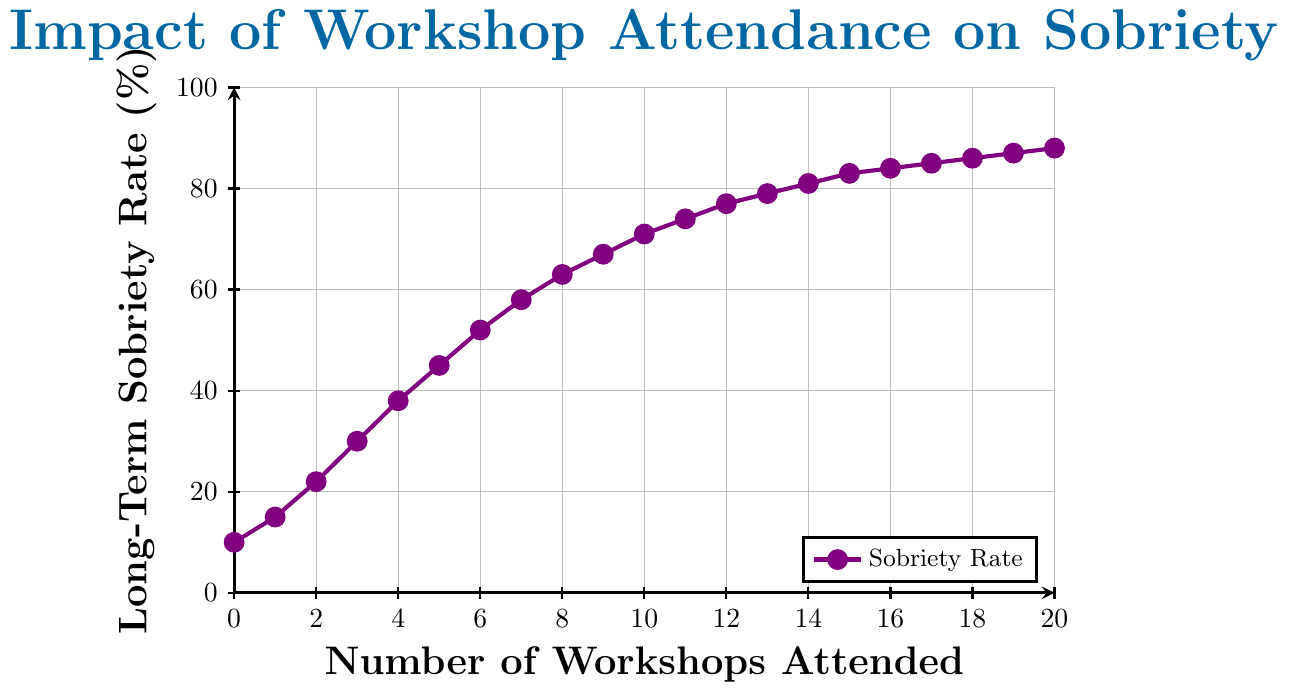What's the trend in long-term sobriety rates as the number of workshops attended increases? Observing the line plot, the long-term sobriety rate increases steadily as the number of workshops attended goes up, starting at 10% for 0 workshops and gradually reaching 88% for 20 workshops.
Answer: Increasing How much does the long-term sobriety rate improve after attending 5 workshops as opposed to attending none? The sobriety rate for 0 workshops is 10%, and for 5 workshops is 45%. The improvement is 45% - 10% = 35%.
Answer: 35% At what point on the number of workshops attended axis does the long-term sobriety rate first surpass 50%? Looking at the line plot, the sobriety rate first surpasses 50% between attending 5 and 6 workshops.
Answer: Between 5 and 6 workshops What is the average long-term sobriety rate for attending 10 and 15 workshops? The sobriety rate for 10 workshops is 71% and for 15 workshops is 83%. The average is (71 + 83) / 2 = 77%.
Answer: 77% How does the sobriety rate for 12 workshops compare to that for 8 workshops? The sobriety rate for 12 workshops is 77%, while for 8 workshops, it is 63%. Therefore, 12 workshops have a higher sobriety rate by 77% - 63% = 14%.
Answer: 14% higher Which color is the line drawn in the plot? The line representing the sobriety rate in the plot is drawn in purple.
Answer: Purple What is the range of long-term sobriety rates shown in the plot? The lowest sobriety rate is 10%, and the highest is 88%. The range is 88% - 10% = 78%.
Answer: 78% Identify the number of workshops attended for which the sobriety rate increases the most compared to the previous workshop. By examining the rate of increase between consecutive points, the increase from 2 workshops (22%) to 3 workshops (30%) is the most significant, which is 30% - 22% = 8%.
Answer: From 2 to 3 workshops Is there any point where the increase in sobriety rate stagnates, and what is the increase at that point? Observing the trend, the increase in the sobriety rate notably slows down as it reaches 20 workshops, with an increase of just 88% - 87% = 1%.
Answer: 1% at 20 workshops 